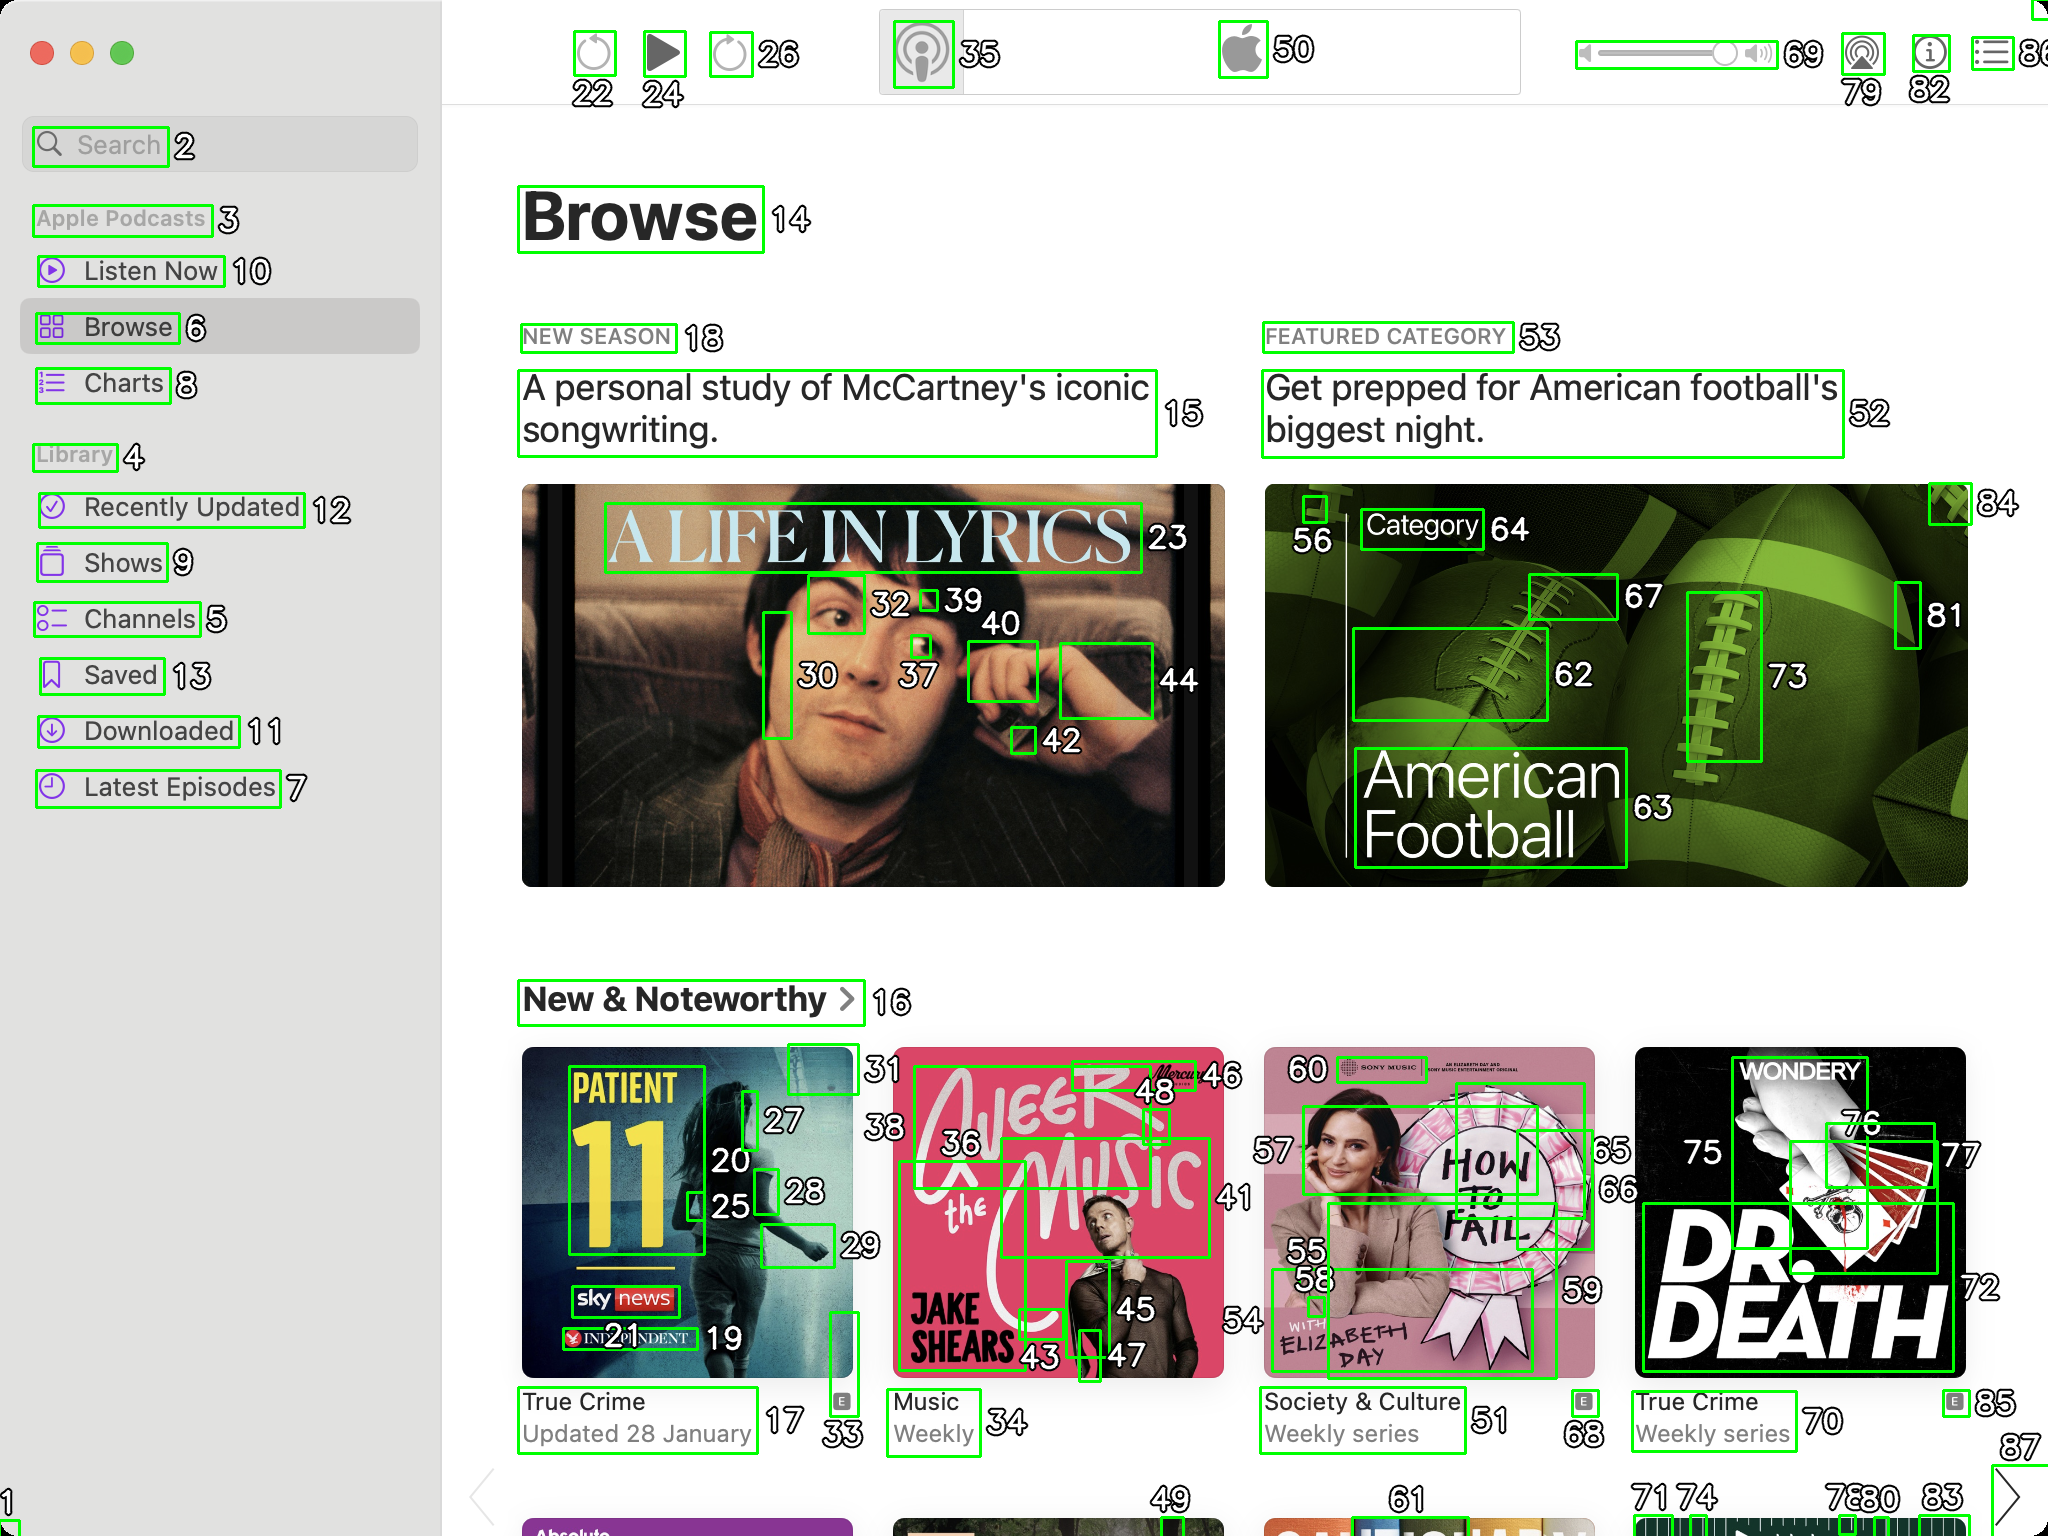You are an AI designed for image processing and segmentation analysis, particularly skilled in merging segmented regions of an image to improve accuracy and readability.

**Task Description:**
Your task is to address a user's concern with a UI screenshot of the Apple Podcasts application on MacOS. The screenshot contains multiple green boxes, each representing a UI element, with a unique white number outlined in black ranging from 1 to 88. Due to segmentation issues, some boxes that belong to the same image are divided unnaturally.

**Objective:**
Merge these segmented areas that correspond to a single UI element to create a coherent representation. The final output should be in JSON format, where each key-value pair represents the merged areas.

**Example JSON Output:**
If boxes with numbers 1, 2, and 3 should belong to the same UI element, the JSON output should be:

```json
{
    "Image A Life In Lyrics": [1, 2, 3]
}
```

**Instructions:**

- **Identify Segmented Regions:** Analyze the screenshot to identify which green boxes belong to the same UI element.
- **Merge Regions:** Group the numbers of these boxes together to represent a single UI element.
- **Output Format:** Produce the output in JSON format, with each key representing a UI element and each value being a list of the numbers of the merged boxes. If UI element contains only one box than omit that element in final result.

**Primary Objective:**
Ensure the accuracy of the merged regions based on the user's supplied image information, maintaining the integrity and structure of the UI elements in the Apple Podcasts application on MacOS. ```json
{
    "Search": [2],
    "Apple Podcasts": [3],
    "Listen Now": [10],
    "Browse": [6, 14],
    "Charts": [8],
    "Library": [4],
    "Recently Updated": [12],
    "Shows": [9],
    "Channels": [5],
    "Saved": [13],
    "Downloaded": [11],
    "Latest Episodes": [7],
    "Play Button": [22, 24],
    "Volume Control": [26, 69],
    "Settings": [35],
    "Apple Logo": [50],
    "A Life In Lyrics": [23, 30, 32, 37, 39, 40, 42, 44],
    "New Season": [18],
    "A personal study of McCartney's iconic songwriting.": [15],
    "Featured Category": [53],
    "Get prepped for American football's biggest night.": [52],
    "American Football": [56, 62, 63, 64, 67, 73, 81, 84],
    "New & Noteworthy": [16],
    "Patient 11": [17, 20, 25, 27, 28, 33],
    "True Crime Updated 28 January": [31],
    "A Beer With The Music": [36, 43, 45, 46, 48],
    "Weekly": [34],
    "How To Fail": [55, 58, 59, 60],
    "Society & Culture Weekly series": [51],
    "Dr. Death": [70, 72, 75, 76, 77],
    "True Crime Weekly series": [68, 85]
}
``` 